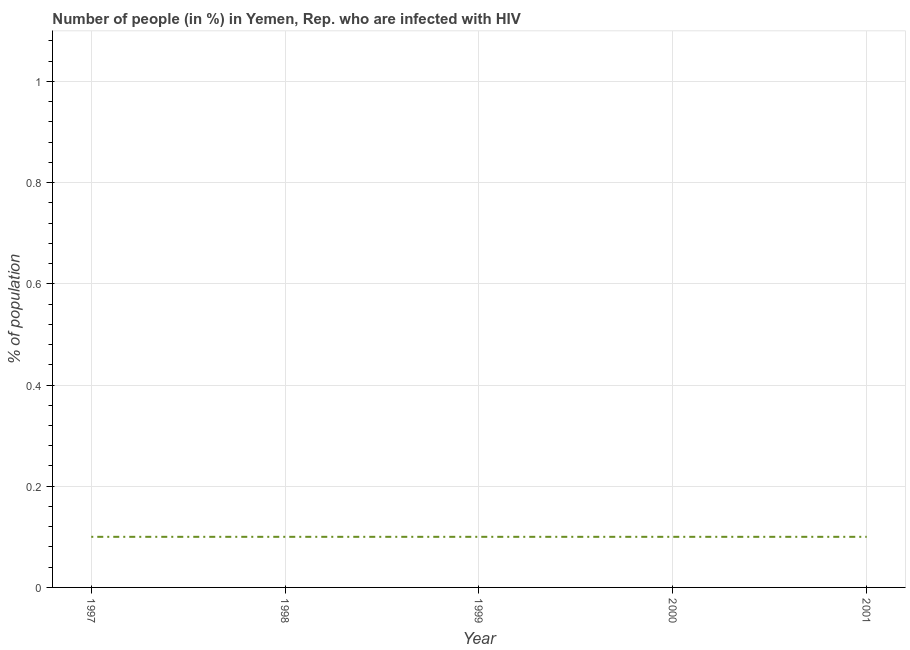What is the number of people infected with hiv in 1999?
Offer a very short reply. 0.1. In which year was the number of people infected with hiv maximum?
Offer a very short reply. 1997. In how many years, is the number of people infected with hiv greater than 0.2 %?
Make the answer very short. 0. What is the ratio of the number of people infected with hiv in 1998 to that in 2000?
Your response must be concise. 1. What is the difference between the highest and the second highest number of people infected with hiv?
Provide a succinct answer. 0. Are the values on the major ticks of Y-axis written in scientific E-notation?
Give a very brief answer. No. What is the title of the graph?
Ensure brevity in your answer.  Number of people (in %) in Yemen, Rep. who are infected with HIV. What is the label or title of the X-axis?
Offer a terse response. Year. What is the label or title of the Y-axis?
Provide a short and direct response. % of population. What is the % of population in 1997?
Your response must be concise. 0.1. What is the % of population in 1998?
Your answer should be very brief. 0.1. What is the % of population of 1999?
Ensure brevity in your answer.  0.1. What is the % of population of 2001?
Give a very brief answer. 0.1. What is the difference between the % of population in 1997 and 1999?
Your response must be concise. 0. What is the difference between the % of population in 1997 and 2000?
Your answer should be very brief. 0. What is the difference between the % of population in 1998 and 2000?
Keep it short and to the point. 0. What is the difference between the % of population in 1998 and 2001?
Your response must be concise. 0. What is the difference between the % of population in 1999 and 2000?
Offer a terse response. 0. What is the difference between the % of population in 2000 and 2001?
Offer a terse response. 0. What is the ratio of the % of population in 1997 to that in 1998?
Offer a terse response. 1. What is the ratio of the % of population in 1997 to that in 2000?
Make the answer very short. 1. What is the ratio of the % of population in 1998 to that in 1999?
Your response must be concise. 1. What is the ratio of the % of population in 1999 to that in 2000?
Ensure brevity in your answer.  1. 